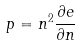Convert formula to latex. <formula><loc_0><loc_0><loc_500><loc_500>p = n ^ { 2 } \frac { \partial e } { \partial n }</formula> 